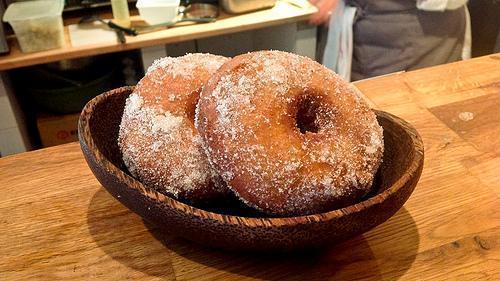How many doughnuts are there?
Give a very brief answer. 2. 